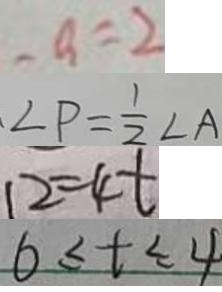Convert formula to latex. <formula><loc_0><loc_0><loc_500><loc_500>- a = 2 
 \angle P = \frac { 1 } { 2 } \angle A 
 1 2 = 4 t 
 6 \leq t \leq 4</formula> 